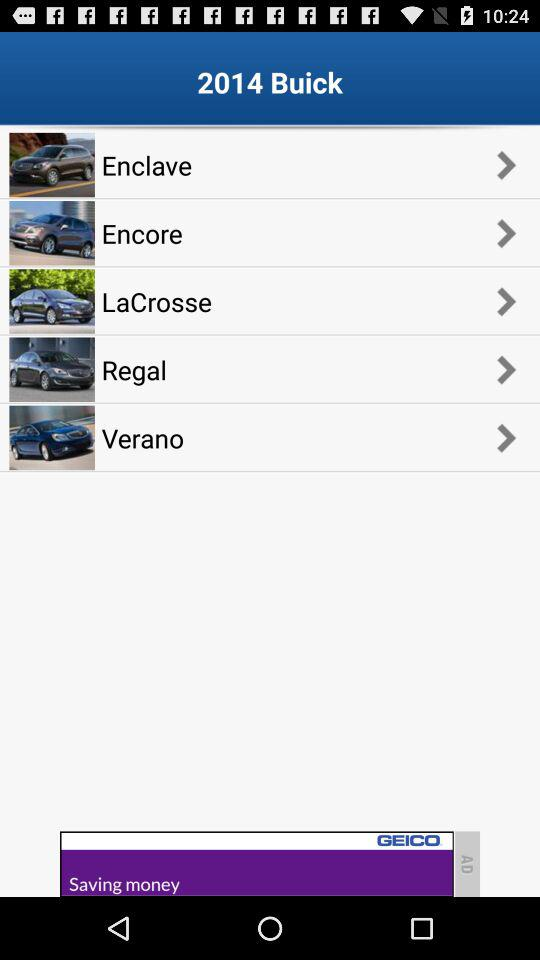How many models are there on this page?
Answer the question using a single word or phrase. 5 